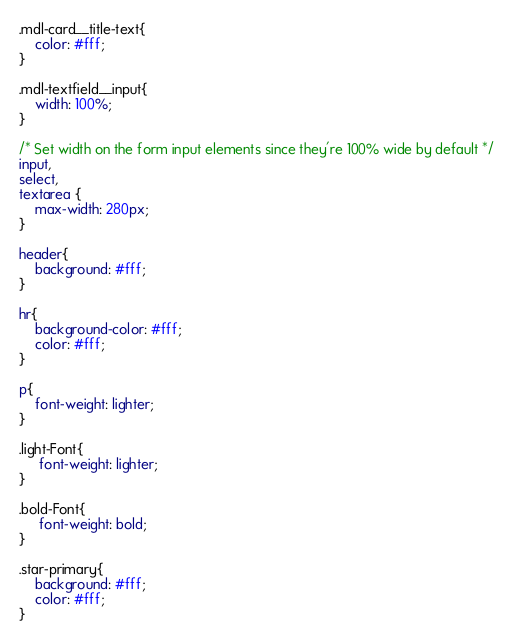<code> <loc_0><loc_0><loc_500><loc_500><_CSS_>
.mdl-card__title-text{
	color: #fff;
}

.mdl-textfield__input{
	width: 100%;
}

/* Set width on the form input elements since they're 100% wide by default */
input,
select,
textarea {
    max-width: 280px;
}

header{
    background: #fff;
}

hr{
    background-color: #fff;
    color: #fff;
}

p{
    font-weight: lighter;
}

.light-Font{
     font-weight: lighter;
}

.bold-Font{
     font-weight: bold;
}

.star-primary{
    background: #fff;
    color: #fff;
}
</code> 